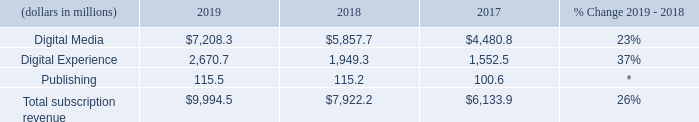Subscription Revenue by Segment
Our subscription revenue is comprised primarily of fees we charge for our subscription and hosted service offerings including Creative Cloud and certain of our Digital Experience and Document Cloud services. We recognize subscription revenue ratably over the term of agreements with our customers, beginning with commencement of service.
We have the following reportable segments: Digital Media, Digital Experience and Publishing. Subscription revenue by reportable segment for fiscal 2019, 2018 and 2017 is as follows:
(*) Percentage is less than 1%
Our product revenue is primarily comprised of revenue from distinct on-premise software licenses recognized at a point in time and certain of our OEM and royalty agreements. Our services and support revenue is comprised of consulting, training and maintenance and support, primarily related to the licensing of our enterprise offerings and the sale of our hosted Digital Experience services. Our support revenue also includes technical support and developer support to partners and developer organizations related to our desktop products. Our maintenance and support offerings, which entitle customers to receive desktop product upgrades and enhancements or technical support, depending on the offering, are generally recognized ratably over the term of the arrangement.
What is the percentage change in publishing between 2018 and 2019?
Answer scale should be: percent. (115.5-115.2)/115.2
Answer: 0.26. What was the percentage change in total subscription revenue for 2018-2017? 
Answer scale should be: percent. (7,922.2 - 6,133.9)/6,133.9 
Answer: 29.15. What is the sum of digital media and digital experience revenue in 2017?
Answer scale should be: million. $4,480.8+$1,552.5
Answer: 6033.3. What does their subscription revenue mainly comprise of? Fees we charge for our subscription and hosted service offerings including creative cloud and certain of our digital experience and document cloud services. What does their product revenue comprise of? Revenue from distinct on-premise software licenses recognized at a point in time and certain of our oem and royalty agreements. What does their services and support revenue comprise of? Consulting, training and maintenance and support, primarily related to the licensing of our enterprise offerings and the sale of our hosted digital experience services. 